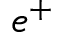<formula> <loc_0><loc_0><loc_500><loc_500>e ^ { + }</formula> 